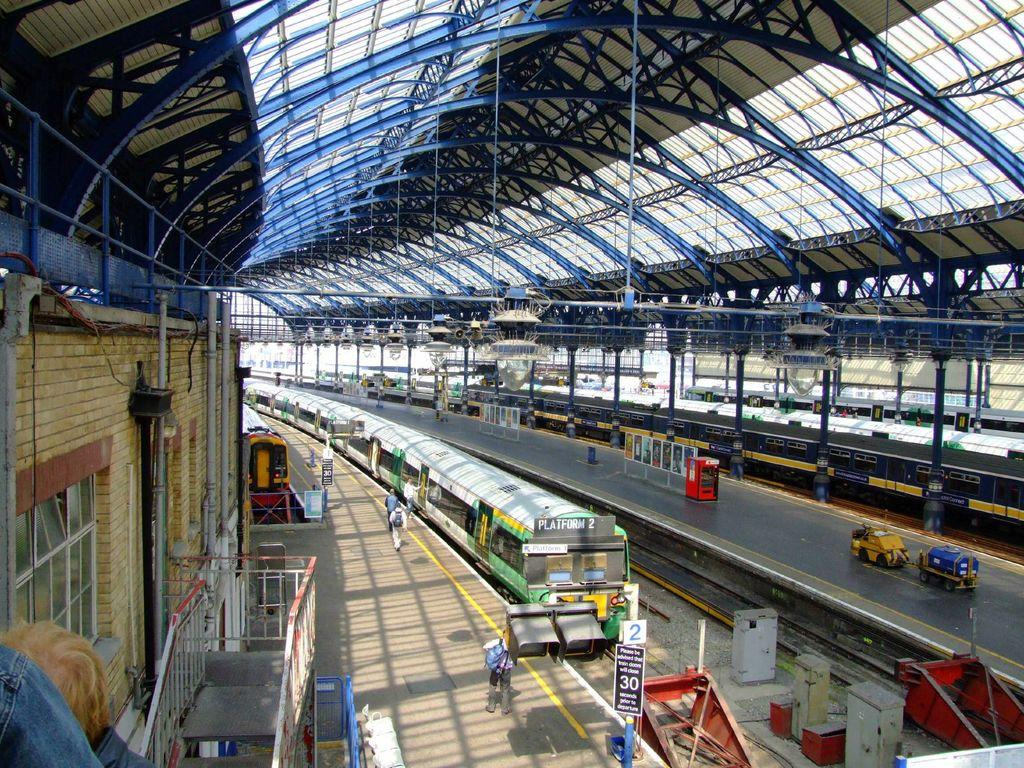What is located at the bottom of the image? At the bottom of the image, there are people, a train, railway tracks, vehicles, platforms, signboards, and a staircase. What can be seen in the middle of the image? In the middle of the image, there are windows, people, a building, and a roof. Can you describe the setting at the bottom of the image? The setting at the bottom of the image is a train station or platform, with people, vehicles, and a train present. What type of snake can be seen slithering through the oatmeal in the image? There is no snake or oatmeal present in the image. What type of voyage is depicted in the image? The image does not depict a voyage; it shows a train station or platform with people, vehicles, and a train. 